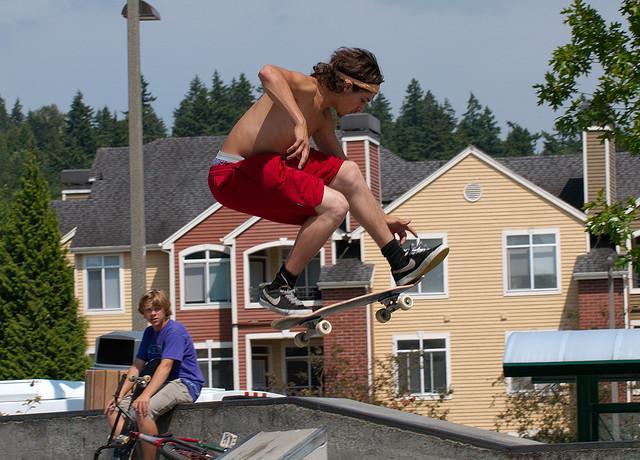How many people are there?
Give a very brief answer. 2. 